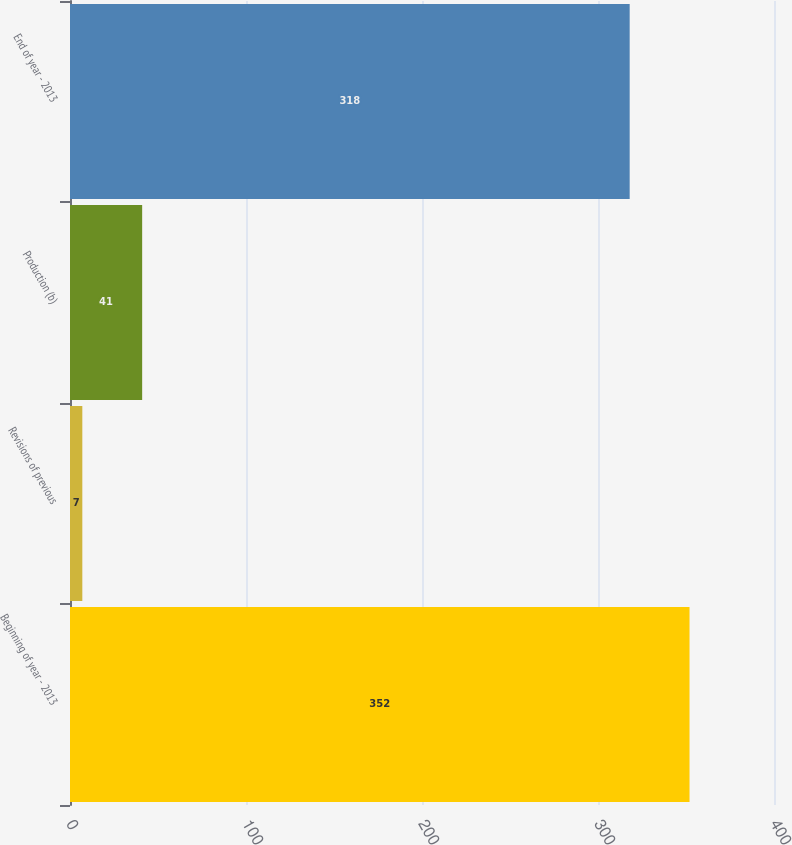<chart> <loc_0><loc_0><loc_500><loc_500><bar_chart><fcel>Beginning of year - 2013<fcel>Revisions of previous<fcel>Production (b)<fcel>End of year - 2013<nl><fcel>352<fcel>7<fcel>41<fcel>318<nl></chart> 